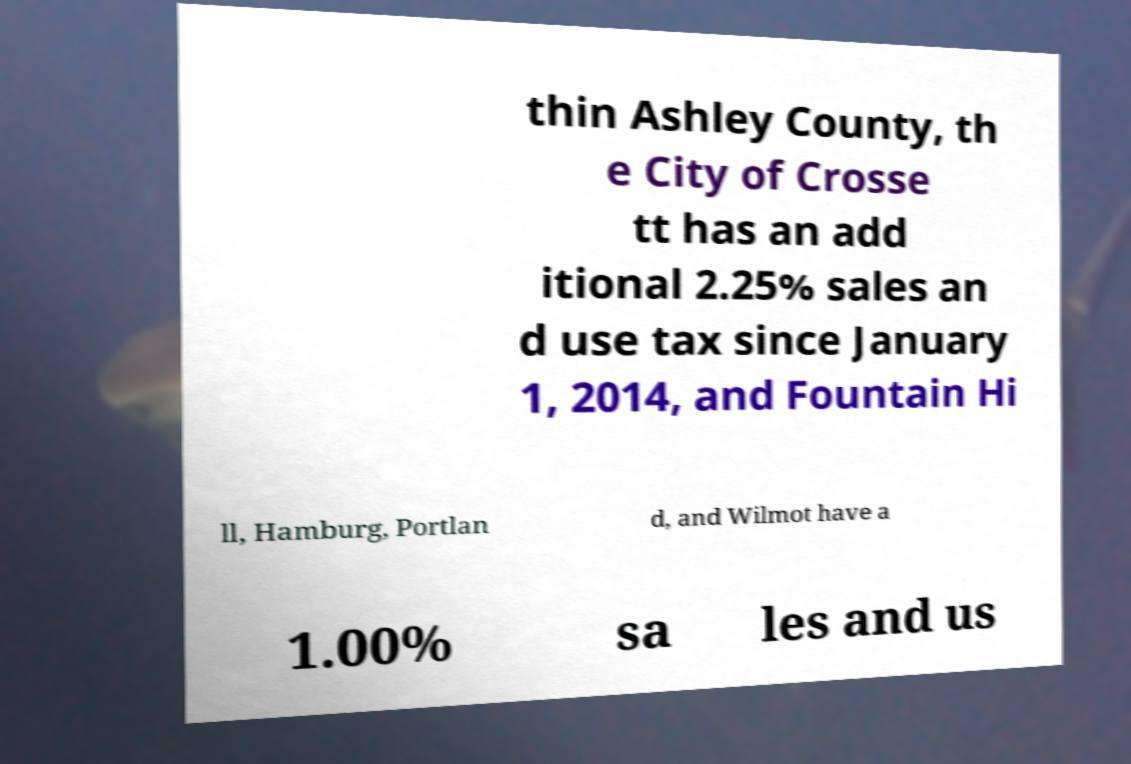For documentation purposes, I need the text within this image transcribed. Could you provide that? thin Ashley County, th e City of Crosse tt has an add itional 2.25% sales an d use tax since January 1, 2014, and Fountain Hi ll, Hamburg, Portlan d, and Wilmot have a 1.00% sa les and us 